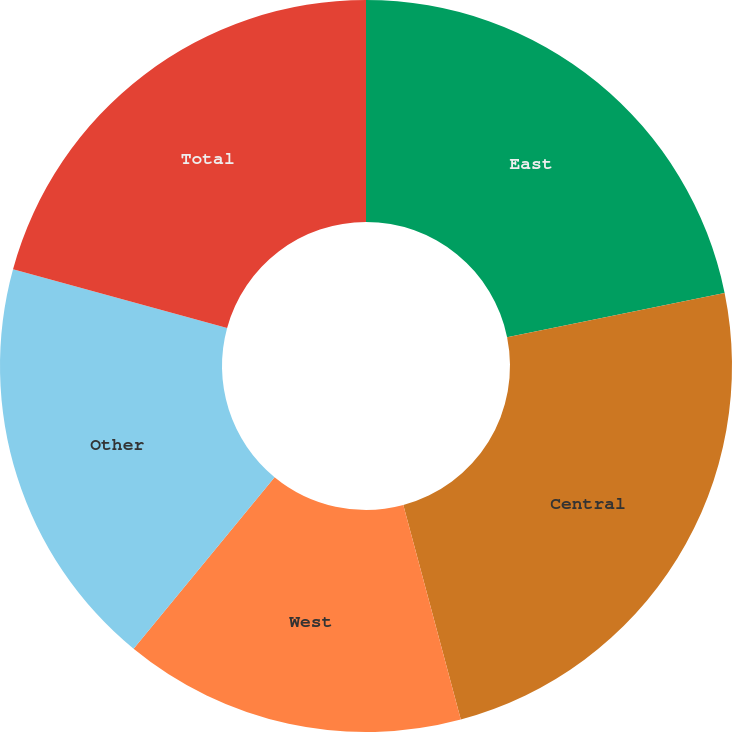<chart> <loc_0><loc_0><loc_500><loc_500><pie_chart><fcel>East<fcel>Central<fcel>West<fcel>Other<fcel>Total<nl><fcel>21.8%<fcel>24.03%<fcel>15.12%<fcel>18.31%<fcel>20.74%<nl></chart> 